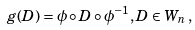Convert formula to latex. <formula><loc_0><loc_0><loc_500><loc_500>g ( D ) = \phi \circ D \circ \phi ^ { - 1 } , D \in W _ { n } \, ,</formula> 